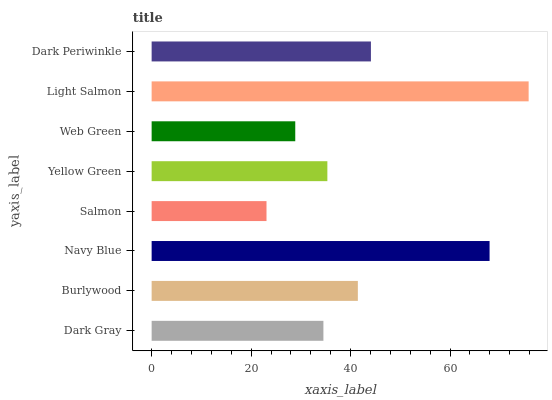Is Salmon the minimum?
Answer yes or no. Yes. Is Light Salmon the maximum?
Answer yes or no. Yes. Is Burlywood the minimum?
Answer yes or no. No. Is Burlywood the maximum?
Answer yes or no. No. Is Burlywood greater than Dark Gray?
Answer yes or no. Yes. Is Dark Gray less than Burlywood?
Answer yes or no. Yes. Is Dark Gray greater than Burlywood?
Answer yes or no. No. Is Burlywood less than Dark Gray?
Answer yes or no. No. Is Burlywood the high median?
Answer yes or no. Yes. Is Yellow Green the low median?
Answer yes or no. Yes. Is Dark Periwinkle the high median?
Answer yes or no. No. Is Burlywood the low median?
Answer yes or no. No. 